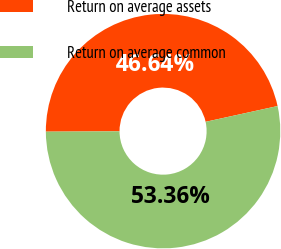<chart> <loc_0><loc_0><loc_500><loc_500><pie_chart><fcel>Return on average assets<fcel>Return on average common<nl><fcel>46.64%<fcel>53.36%<nl></chart> 